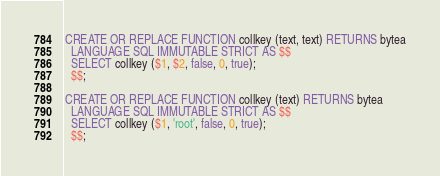<code> <loc_0><loc_0><loc_500><loc_500><_SQL_>
CREATE OR REPLACE FUNCTION collkey (text, text) RETURNS bytea
  LANGUAGE SQL IMMUTABLE STRICT AS $$
  SELECT collkey ($1, $2, false, 0, true);
  $$;

CREATE OR REPLACE FUNCTION collkey (text) RETURNS bytea
  LANGUAGE SQL IMMUTABLE STRICT AS $$
  SELECT collkey ($1, 'root', false, 0, true);
  $$;

</code> 